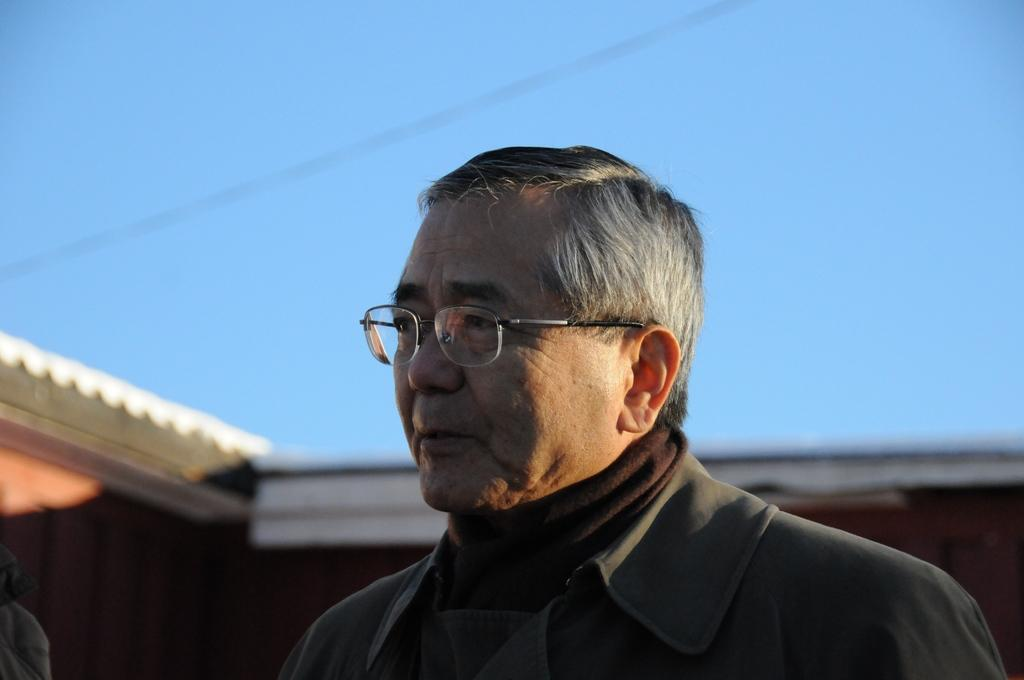What is the main subject in the foreground of the image? There is a person in the foreground of the image. What can be observed about the person's appearance? The person is wearing spectacles. What structure can be seen in the background of the image? There is a house in the background of the image. What is visible at the top of the image? The sky is visible at the top of the image. What type of crook can be seen in the bedroom in the image? There is no bedroom or crook present in the image. How many rooms are visible in the image? The image only shows a person in the foreground, a house in the background, and the sky, so it is not possible to determine the number of rooms. 